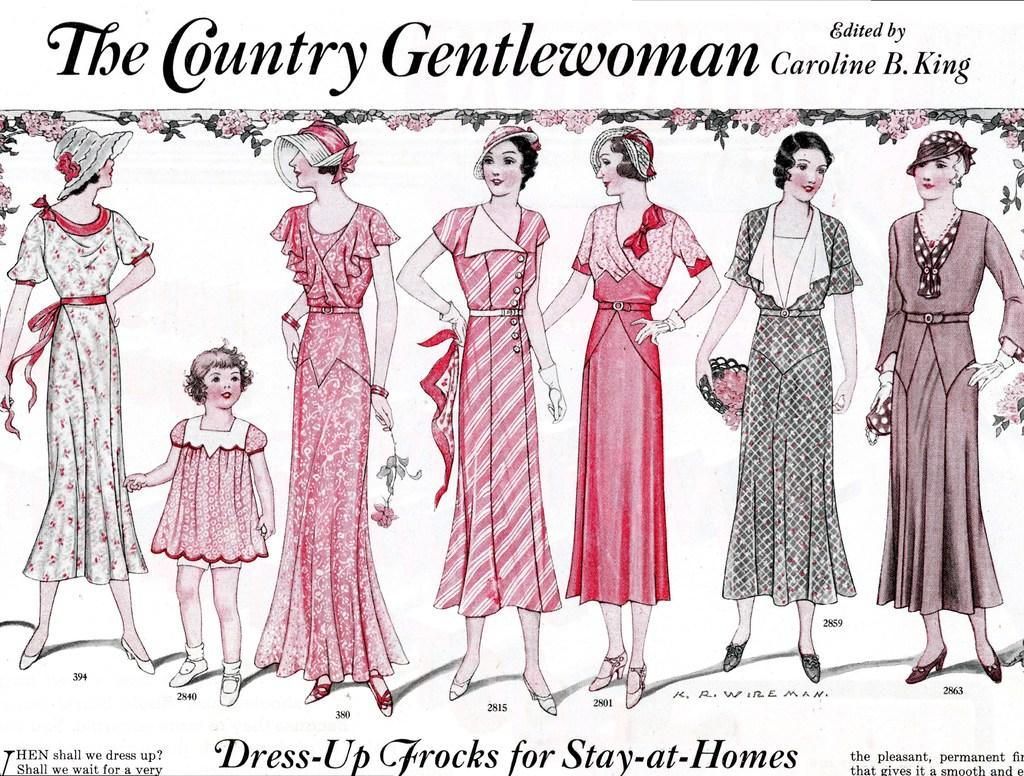What is the main subject of the image? The main subject of the image is a photo. What can be seen in the photo? The photo contains women standing. Are there any words or letters on the photo? Yes, there is text on the photo. Can you tell me how many yokes are visible in the photo? There are no yokes visible in the photo; it features women standing with text on it. What type of pancake can be seen in the photo? There is no pancake present in the photo. 